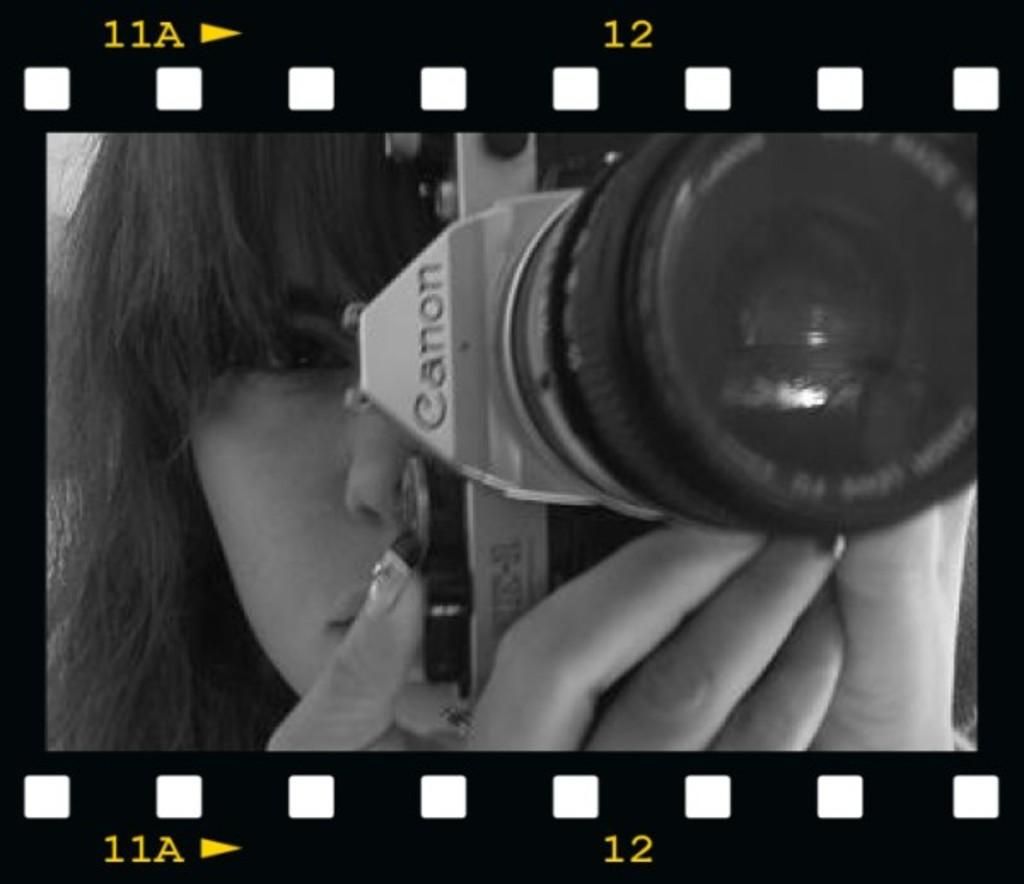What is the main subject of the image? The main subject of the image is a woman. What is the woman holding in her hand? The woman is holding a camera in her hand. What decision is the squirrel making in the image? There is no squirrel present in the image, so it is not possible to determine what decision it might be making. 